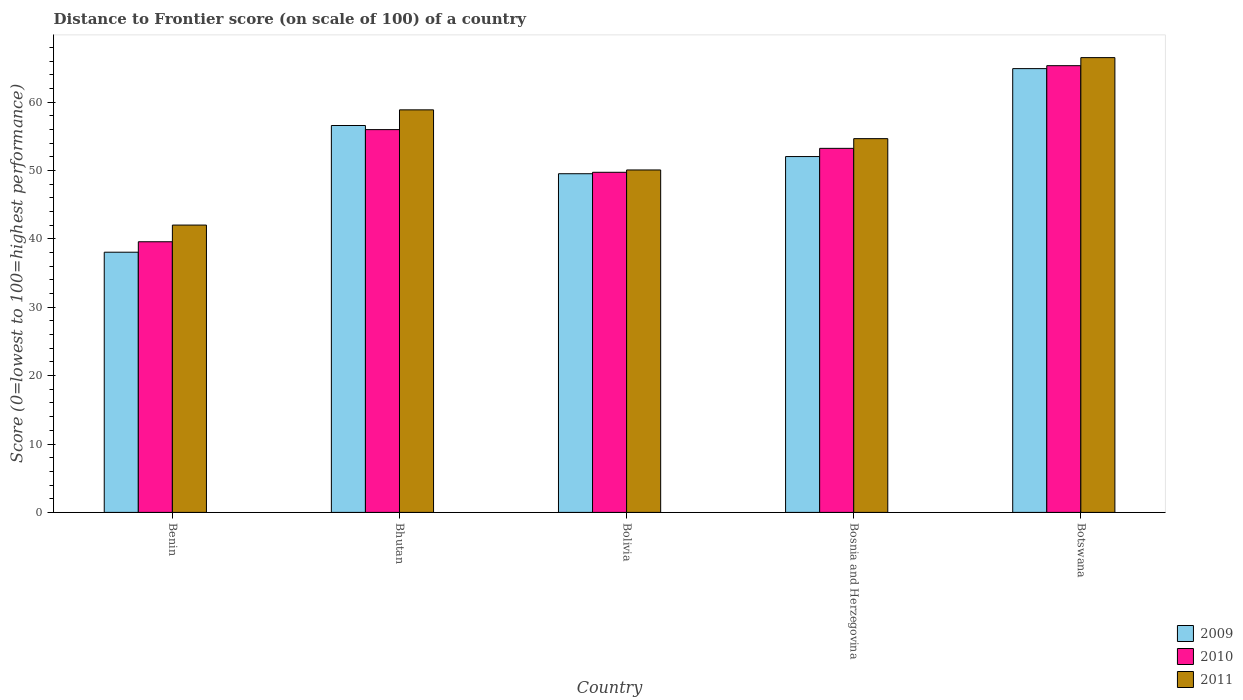How many different coloured bars are there?
Ensure brevity in your answer.  3. How many groups of bars are there?
Keep it short and to the point. 5. Are the number of bars per tick equal to the number of legend labels?
Your answer should be very brief. Yes. Are the number of bars on each tick of the X-axis equal?
Ensure brevity in your answer.  Yes. How many bars are there on the 5th tick from the left?
Your answer should be compact. 3. What is the label of the 1st group of bars from the left?
Provide a succinct answer. Benin. What is the distance to frontier score of in 2010 in Bosnia and Herzegovina?
Provide a short and direct response. 53.24. Across all countries, what is the maximum distance to frontier score of in 2010?
Ensure brevity in your answer.  65.33. Across all countries, what is the minimum distance to frontier score of in 2010?
Make the answer very short. 39.58. In which country was the distance to frontier score of in 2011 maximum?
Ensure brevity in your answer.  Botswana. In which country was the distance to frontier score of in 2010 minimum?
Ensure brevity in your answer.  Benin. What is the total distance to frontier score of in 2009 in the graph?
Offer a terse response. 261.1. What is the difference between the distance to frontier score of in 2011 in Benin and that in Bosnia and Herzegovina?
Provide a short and direct response. -12.64. What is the difference between the distance to frontier score of in 2009 in Bhutan and the distance to frontier score of in 2011 in Botswana?
Offer a very short reply. -9.93. What is the average distance to frontier score of in 2009 per country?
Provide a short and direct response. 52.22. What is the difference between the distance to frontier score of of/in 2009 and distance to frontier score of of/in 2011 in Bhutan?
Your answer should be compact. -2.29. In how many countries, is the distance to frontier score of in 2011 greater than 58?
Provide a succinct answer. 2. What is the ratio of the distance to frontier score of in 2009 in Bolivia to that in Bosnia and Herzegovina?
Keep it short and to the point. 0.95. Is the difference between the distance to frontier score of in 2009 in Benin and Botswana greater than the difference between the distance to frontier score of in 2011 in Benin and Botswana?
Offer a very short reply. No. What is the difference between the highest and the second highest distance to frontier score of in 2010?
Give a very brief answer. 12.09. What is the difference between the highest and the lowest distance to frontier score of in 2010?
Provide a succinct answer. 25.75. What does the 3rd bar from the left in Bolivia represents?
Your answer should be compact. 2011. How many bars are there?
Provide a succinct answer. 15. Are all the bars in the graph horizontal?
Provide a short and direct response. No. How many countries are there in the graph?
Give a very brief answer. 5. What is the title of the graph?
Provide a succinct answer. Distance to Frontier score (on scale of 100) of a country. Does "1990" appear as one of the legend labels in the graph?
Give a very brief answer. No. What is the label or title of the Y-axis?
Your answer should be very brief. Score (0=lowest to 100=highest performance). What is the Score (0=lowest to 100=highest performance) of 2009 in Benin?
Give a very brief answer. 38.05. What is the Score (0=lowest to 100=highest performance) of 2010 in Benin?
Keep it short and to the point. 39.58. What is the Score (0=lowest to 100=highest performance) in 2011 in Benin?
Make the answer very short. 42.02. What is the Score (0=lowest to 100=highest performance) of 2009 in Bhutan?
Keep it short and to the point. 56.58. What is the Score (0=lowest to 100=highest performance) in 2010 in Bhutan?
Ensure brevity in your answer.  55.98. What is the Score (0=lowest to 100=highest performance) in 2011 in Bhutan?
Offer a terse response. 58.87. What is the Score (0=lowest to 100=highest performance) in 2009 in Bolivia?
Ensure brevity in your answer.  49.53. What is the Score (0=lowest to 100=highest performance) in 2010 in Bolivia?
Ensure brevity in your answer.  49.74. What is the Score (0=lowest to 100=highest performance) of 2011 in Bolivia?
Keep it short and to the point. 50.08. What is the Score (0=lowest to 100=highest performance) in 2009 in Bosnia and Herzegovina?
Your response must be concise. 52.04. What is the Score (0=lowest to 100=highest performance) in 2010 in Bosnia and Herzegovina?
Offer a terse response. 53.24. What is the Score (0=lowest to 100=highest performance) of 2011 in Bosnia and Herzegovina?
Provide a succinct answer. 54.66. What is the Score (0=lowest to 100=highest performance) of 2009 in Botswana?
Ensure brevity in your answer.  64.9. What is the Score (0=lowest to 100=highest performance) in 2010 in Botswana?
Your answer should be very brief. 65.33. What is the Score (0=lowest to 100=highest performance) of 2011 in Botswana?
Provide a short and direct response. 66.51. Across all countries, what is the maximum Score (0=lowest to 100=highest performance) of 2009?
Provide a succinct answer. 64.9. Across all countries, what is the maximum Score (0=lowest to 100=highest performance) in 2010?
Make the answer very short. 65.33. Across all countries, what is the maximum Score (0=lowest to 100=highest performance) in 2011?
Your response must be concise. 66.51. Across all countries, what is the minimum Score (0=lowest to 100=highest performance) in 2009?
Your response must be concise. 38.05. Across all countries, what is the minimum Score (0=lowest to 100=highest performance) of 2010?
Offer a terse response. 39.58. Across all countries, what is the minimum Score (0=lowest to 100=highest performance) in 2011?
Ensure brevity in your answer.  42.02. What is the total Score (0=lowest to 100=highest performance) of 2009 in the graph?
Make the answer very short. 261.1. What is the total Score (0=lowest to 100=highest performance) of 2010 in the graph?
Your answer should be compact. 263.87. What is the total Score (0=lowest to 100=highest performance) in 2011 in the graph?
Your answer should be very brief. 272.14. What is the difference between the Score (0=lowest to 100=highest performance) of 2009 in Benin and that in Bhutan?
Provide a succinct answer. -18.53. What is the difference between the Score (0=lowest to 100=highest performance) of 2010 in Benin and that in Bhutan?
Make the answer very short. -16.4. What is the difference between the Score (0=lowest to 100=highest performance) in 2011 in Benin and that in Bhutan?
Your answer should be compact. -16.85. What is the difference between the Score (0=lowest to 100=highest performance) in 2009 in Benin and that in Bolivia?
Keep it short and to the point. -11.48. What is the difference between the Score (0=lowest to 100=highest performance) in 2010 in Benin and that in Bolivia?
Ensure brevity in your answer.  -10.16. What is the difference between the Score (0=lowest to 100=highest performance) of 2011 in Benin and that in Bolivia?
Offer a terse response. -8.06. What is the difference between the Score (0=lowest to 100=highest performance) in 2009 in Benin and that in Bosnia and Herzegovina?
Offer a very short reply. -13.99. What is the difference between the Score (0=lowest to 100=highest performance) of 2010 in Benin and that in Bosnia and Herzegovina?
Your answer should be compact. -13.66. What is the difference between the Score (0=lowest to 100=highest performance) of 2011 in Benin and that in Bosnia and Herzegovina?
Ensure brevity in your answer.  -12.64. What is the difference between the Score (0=lowest to 100=highest performance) in 2009 in Benin and that in Botswana?
Give a very brief answer. -26.85. What is the difference between the Score (0=lowest to 100=highest performance) in 2010 in Benin and that in Botswana?
Provide a succinct answer. -25.75. What is the difference between the Score (0=lowest to 100=highest performance) of 2011 in Benin and that in Botswana?
Give a very brief answer. -24.49. What is the difference between the Score (0=lowest to 100=highest performance) in 2009 in Bhutan and that in Bolivia?
Keep it short and to the point. 7.05. What is the difference between the Score (0=lowest to 100=highest performance) of 2010 in Bhutan and that in Bolivia?
Provide a short and direct response. 6.24. What is the difference between the Score (0=lowest to 100=highest performance) of 2011 in Bhutan and that in Bolivia?
Keep it short and to the point. 8.79. What is the difference between the Score (0=lowest to 100=highest performance) of 2009 in Bhutan and that in Bosnia and Herzegovina?
Your answer should be very brief. 4.54. What is the difference between the Score (0=lowest to 100=highest performance) of 2010 in Bhutan and that in Bosnia and Herzegovina?
Your answer should be compact. 2.74. What is the difference between the Score (0=lowest to 100=highest performance) of 2011 in Bhutan and that in Bosnia and Herzegovina?
Your answer should be compact. 4.21. What is the difference between the Score (0=lowest to 100=highest performance) of 2009 in Bhutan and that in Botswana?
Provide a succinct answer. -8.32. What is the difference between the Score (0=lowest to 100=highest performance) of 2010 in Bhutan and that in Botswana?
Give a very brief answer. -9.35. What is the difference between the Score (0=lowest to 100=highest performance) of 2011 in Bhutan and that in Botswana?
Offer a terse response. -7.64. What is the difference between the Score (0=lowest to 100=highest performance) of 2009 in Bolivia and that in Bosnia and Herzegovina?
Give a very brief answer. -2.51. What is the difference between the Score (0=lowest to 100=highest performance) in 2010 in Bolivia and that in Bosnia and Herzegovina?
Your response must be concise. -3.5. What is the difference between the Score (0=lowest to 100=highest performance) of 2011 in Bolivia and that in Bosnia and Herzegovina?
Offer a very short reply. -4.58. What is the difference between the Score (0=lowest to 100=highest performance) in 2009 in Bolivia and that in Botswana?
Ensure brevity in your answer.  -15.37. What is the difference between the Score (0=lowest to 100=highest performance) in 2010 in Bolivia and that in Botswana?
Your answer should be compact. -15.59. What is the difference between the Score (0=lowest to 100=highest performance) of 2011 in Bolivia and that in Botswana?
Provide a short and direct response. -16.43. What is the difference between the Score (0=lowest to 100=highest performance) of 2009 in Bosnia and Herzegovina and that in Botswana?
Provide a short and direct response. -12.86. What is the difference between the Score (0=lowest to 100=highest performance) in 2010 in Bosnia and Herzegovina and that in Botswana?
Offer a very short reply. -12.09. What is the difference between the Score (0=lowest to 100=highest performance) of 2011 in Bosnia and Herzegovina and that in Botswana?
Your answer should be compact. -11.85. What is the difference between the Score (0=lowest to 100=highest performance) in 2009 in Benin and the Score (0=lowest to 100=highest performance) in 2010 in Bhutan?
Offer a terse response. -17.93. What is the difference between the Score (0=lowest to 100=highest performance) in 2009 in Benin and the Score (0=lowest to 100=highest performance) in 2011 in Bhutan?
Offer a terse response. -20.82. What is the difference between the Score (0=lowest to 100=highest performance) in 2010 in Benin and the Score (0=lowest to 100=highest performance) in 2011 in Bhutan?
Keep it short and to the point. -19.29. What is the difference between the Score (0=lowest to 100=highest performance) in 2009 in Benin and the Score (0=lowest to 100=highest performance) in 2010 in Bolivia?
Give a very brief answer. -11.69. What is the difference between the Score (0=lowest to 100=highest performance) of 2009 in Benin and the Score (0=lowest to 100=highest performance) of 2011 in Bolivia?
Keep it short and to the point. -12.03. What is the difference between the Score (0=lowest to 100=highest performance) in 2010 in Benin and the Score (0=lowest to 100=highest performance) in 2011 in Bolivia?
Keep it short and to the point. -10.5. What is the difference between the Score (0=lowest to 100=highest performance) in 2009 in Benin and the Score (0=lowest to 100=highest performance) in 2010 in Bosnia and Herzegovina?
Keep it short and to the point. -15.19. What is the difference between the Score (0=lowest to 100=highest performance) in 2009 in Benin and the Score (0=lowest to 100=highest performance) in 2011 in Bosnia and Herzegovina?
Your answer should be compact. -16.61. What is the difference between the Score (0=lowest to 100=highest performance) of 2010 in Benin and the Score (0=lowest to 100=highest performance) of 2011 in Bosnia and Herzegovina?
Provide a short and direct response. -15.08. What is the difference between the Score (0=lowest to 100=highest performance) of 2009 in Benin and the Score (0=lowest to 100=highest performance) of 2010 in Botswana?
Give a very brief answer. -27.28. What is the difference between the Score (0=lowest to 100=highest performance) in 2009 in Benin and the Score (0=lowest to 100=highest performance) in 2011 in Botswana?
Keep it short and to the point. -28.46. What is the difference between the Score (0=lowest to 100=highest performance) in 2010 in Benin and the Score (0=lowest to 100=highest performance) in 2011 in Botswana?
Give a very brief answer. -26.93. What is the difference between the Score (0=lowest to 100=highest performance) of 2009 in Bhutan and the Score (0=lowest to 100=highest performance) of 2010 in Bolivia?
Your answer should be compact. 6.84. What is the difference between the Score (0=lowest to 100=highest performance) of 2009 in Bhutan and the Score (0=lowest to 100=highest performance) of 2011 in Bolivia?
Provide a short and direct response. 6.5. What is the difference between the Score (0=lowest to 100=highest performance) in 2009 in Bhutan and the Score (0=lowest to 100=highest performance) in 2010 in Bosnia and Herzegovina?
Give a very brief answer. 3.34. What is the difference between the Score (0=lowest to 100=highest performance) of 2009 in Bhutan and the Score (0=lowest to 100=highest performance) of 2011 in Bosnia and Herzegovina?
Provide a short and direct response. 1.92. What is the difference between the Score (0=lowest to 100=highest performance) of 2010 in Bhutan and the Score (0=lowest to 100=highest performance) of 2011 in Bosnia and Herzegovina?
Offer a very short reply. 1.32. What is the difference between the Score (0=lowest to 100=highest performance) in 2009 in Bhutan and the Score (0=lowest to 100=highest performance) in 2010 in Botswana?
Your answer should be compact. -8.75. What is the difference between the Score (0=lowest to 100=highest performance) of 2009 in Bhutan and the Score (0=lowest to 100=highest performance) of 2011 in Botswana?
Keep it short and to the point. -9.93. What is the difference between the Score (0=lowest to 100=highest performance) of 2010 in Bhutan and the Score (0=lowest to 100=highest performance) of 2011 in Botswana?
Offer a terse response. -10.53. What is the difference between the Score (0=lowest to 100=highest performance) in 2009 in Bolivia and the Score (0=lowest to 100=highest performance) in 2010 in Bosnia and Herzegovina?
Give a very brief answer. -3.71. What is the difference between the Score (0=lowest to 100=highest performance) of 2009 in Bolivia and the Score (0=lowest to 100=highest performance) of 2011 in Bosnia and Herzegovina?
Your response must be concise. -5.13. What is the difference between the Score (0=lowest to 100=highest performance) of 2010 in Bolivia and the Score (0=lowest to 100=highest performance) of 2011 in Bosnia and Herzegovina?
Keep it short and to the point. -4.92. What is the difference between the Score (0=lowest to 100=highest performance) of 2009 in Bolivia and the Score (0=lowest to 100=highest performance) of 2010 in Botswana?
Offer a very short reply. -15.8. What is the difference between the Score (0=lowest to 100=highest performance) of 2009 in Bolivia and the Score (0=lowest to 100=highest performance) of 2011 in Botswana?
Make the answer very short. -16.98. What is the difference between the Score (0=lowest to 100=highest performance) of 2010 in Bolivia and the Score (0=lowest to 100=highest performance) of 2011 in Botswana?
Make the answer very short. -16.77. What is the difference between the Score (0=lowest to 100=highest performance) of 2009 in Bosnia and Herzegovina and the Score (0=lowest to 100=highest performance) of 2010 in Botswana?
Provide a short and direct response. -13.29. What is the difference between the Score (0=lowest to 100=highest performance) of 2009 in Bosnia and Herzegovina and the Score (0=lowest to 100=highest performance) of 2011 in Botswana?
Your response must be concise. -14.47. What is the difference between the Score (0=lowest to 100=highest performance) of 2010 in Bosnia and Herzegovina and the Score (0=lowest to 100=highest performance) of 2011 in Botswana?
Ensure brevity in your answer.  -13.27. What is the average Score (0=lowest to 100=highest performance) of 2009 per country?
Your answer should be very brief. 52.22. What is the average Score (0=lowest to 100=highest performance) of 2010 per country?
Your answer should be very brief. 52.77. What is the average Score (0=lowest to 100=highest performance) of 2011 per country?
Provide a succinct answer. 54.43. What is the difference between the Score (0=lowest to 100=highest performance) in 2009 and Score (0=lowest to 100=highest performance) in 2010 in Benin?
Provide a short and direct response. -1.53. What is the difference between the Score (0=lowest to 100=highest performance) of 2009 and Score (0=lowest to 100=highest performance) of 2011 in Benin?
Provide a succinct answer. -3.97. What is the difference between the Score (0=lowest to 100=highest performance) in 2010 and Score (0=lowest to 100=highest performance) in 2011 in Benin?
Your response must be concise. -2.44. What is the difference between the Score (0=lowest to 100=highest performance) of 2009 and Score (0=lowest to 100=highest performance) of 2011 in Bhutan?
Provide a short and direct response. -2.29. What is the difference between the Score (0=lowest to 100=highest performance) of 2010 and Score (0=lowest to 100=highest performance) of 2011 in Bhutan?
Your response must be concise. -2.89. What is the difference between the Score (0=lowest to 100=highest performance) in 2009 and Score (0=lowest to 100=highest performance) in 2010 in Bolivia?
Offer a terse response. -0.21. What is the difference between the Score (0=lowest to 100=highest performance) of 2009 and Score (0=lowest to 100=highest performance) of 2011 in Bolivia?
Your answer should be compact. -0.55. What is the difference between the Score (0=lowest to 100=highest performance) in 2010 and Score (0=lowest to 100=highest performance) in 2011 in Bolivia?
Your answer should be compact. -0.34. What is the difference between the Score (0=lowest to 100=highest performance) of 2009 and Score (0=lowest to 100=highest performance) of 2010 in Bosnia and Herzegovina?
Provide a succinct answer. -1.2. What is the difference between the Score (0=lowest to 100=highest performance) in 2009 and Score (0=lowest to 100=highest performance) in 2011 in Bosnia and Herzegovina?
Provide a succinct answer. -2.62. What is the difference between the Score (0=lowest to 100=highest performance) in 2010 and Score (0=lowest to 100=highest performance) in 2011 in Bosnia and Herzegovina?
Keep it short and to the point. -1.42. What is the difference between the Score (0=lowest to 100=highest performance) in 2009 and Score (0=lowest to 100=highest performance) in 2010 in Botswana?
Your answer should be very brief. -0.43. What is the difference between the Score (0=lowest to 100=highest performance) in 2009 and Score (0=lowest to 100=highest performance) in 2011 in Botswana?
Ensure brevity in your answer.  -1.61. What is the difference between the Score (0=lowest to 100=highest performance) of 2010 and Score (0=lowest to 100=highest performance) of 2011 in Botswana?
Provide a short and direct response. -1.18. What is the ratio of the Score (0=lowest to 100=highest performance) in 2009 in Benin to that in Bhutan?
Offer a terse response. 0.67. What is the ratio of the Score (0=lowest to 100=highest performance) of 2010 in Benin to that in Bhutan?
Give a very brief answer. 0.71. What is the ratio of the Score (0=lowest to 100=highest performance) of 2011 in Benin to that in Bhutan?
Make the answer very short. 0.71. What is the ratio of the Score (0=lowest to 100=highest performance) of 2009 in Benin to that in Bolivia?
Your answer should be compact. 0.77. What is the ratio of the Score (0=lowest to 100=highest performance) of 2010 in Benin to that in Bolivia?
Ensure brevity in your answer.  0.8. What is the ratio of the Score (0=lowest to 100=highest performance) of 2011 in Benin to that in Bolivia?
Provide a short and direct response. 0.84. What is the ratio of the Score (0=lowest to 100=highest performance) of 2009 in Benin to that in Bosnia and Herzegovina?
Your answer should be very brief. 0.73. What is the ratio of the Score (0=lowest to 100=highest performance) of 2010 in Benin to that in Bosnia and Herzegovina?
Your answer should be compact. 0.74. What is the ratio of the Score (0=lowest to 100=highest performance) of 2011 in Benin to that in Bosnia and Herzegovina?
Provide a short and direct response. 0.77. What is the ratio of the Score (0=lowest to 100=highest performance) of 2009 in Benin to that in Botswana?
Provide a short and direct response. 0.59. What is the ratio of the Score (0=lowest to 100=highest performance) of 2010 in Benin to that in Botswana?
Make the answer very short. 0.61. What is the ratio of the Score (0=lowest to 100=highest performance) in 2011 in Benin to that in Botswana?
Provide a succinct answer. 0.63. What is the ratio of the Score (0=lowest to 100=highest performance) of 2009 in Bhutan to that in Bolivia?
Provide a short and direct response. 1.14. What is the ratio of the Score (0=lowest to 100=highest performance) of 2010 in Bhutan to that in Bolivia?
Offer a terse response. 1.13. What is the ratio of the Score (0=lowest to 100=highest performance) in 2011 in Bhutan to that in Bolivia?
Offer a terse response. 1.18. What is the ratio of the Score (0=lowest to 100=highest performance) of 2009 in Bhutan to that in Bosnia and Herzegovina?
Provide a short and direct response. 1.09. What is the ratio of the Score (0=lowest to 100=highest performance) in 2010 in Bhutan to that in Bosnia and Herzegovina?
Make the answer very short. 1.05. What is the ratio of the Score (0=lowest to 100=highest performance) of 2011 in Bhutan to that in Bosnia and Herzegovina?
Make the answer very short. 1.08. What is the ratio of the Score (0=lowest to 100=highest performance) in 2009 in Bhutan to that in Botswana?
Your response must be concise. 0.87. What is the ratio of the Score (0=lowest to 100=highest performance) of 2010 in Bhutan to that in Botswana?
Keep it short and to the point. 0.86. What is the ratio of the Score (0=lowest to 100=highest performance) of 2011 in Bhutan to that in Botswana?
Offer a very short reply. 0.89. What is the ratio of the Score (0=lowest to 100=highest performance) in 2009 in Bolivia to that in Bosnia and Herzegovina?
Your answer should be compact. 0.95. What is the ratio of the Score (0=lowest to 100=highest performance) in 2010 in Bolivia to that in Bosnia and Herzegovina?
Provide a succinct answer. 0.93. What is the ratio of the Score (0=lowest to 100=highest performance) in 2011 in Bolivia to that in Bosnia and Herzegovina?
Keep it short and to the point. 0.92. What is the ratio of the Score (0=lowest to 100=highest performance) of 2009 in Bolivia to that in Botswana?
Make the answer very short. 0.76. What is the ratio of the Score (0=lowest to 100=highest performance) in 2010 in Bolivia to that in Botswana?
Your response must be concise. 0.76. What is the ratio of the Score (0=lowest to 100=highest performance) in 2011 in Bolivia to that in Botswana?
Offer a terse response. 0.75. What is the ratio of the Score (0=lowest to 100=highest performance) of 2009 in Bosnia and Herzegovina to that in Botswana?
Your answer should be very brief. 0.8. What is the ratio of the Score (0=lowest to 100=highest performance) of 2010 in Bosnia and Herzegovina to that in Botswana?
Your answer should be compact. 0.81. What is the ratio of the Score (0=lowest to 100=highest performance) in 2011 in Bosnia and Herzegovina to that in Botswana?
Make the answer very short. 0.82. What is the difference between the highest and the second highest Score (0=lowest to 100=highest performance) of 2009?
Provide a short and direct response. 8.32. What is the difference between the highest and the second highest Score (0=lowest to 100=highest performance) in 2010?
Give a very brief answer. 9.35. What is the difference between the highest and the second highest Score (0=lowest to 100=highest performance) of 2011?
Offer a terse response. 7.64. What is the difference between the highest and the lowest Score (0=lowest to 100=highest performance) in 2009?
Ensure brevity in your answer.  26.85. What is the difference between the highest and the lowest Score (0=lowest to 100=highest performance) of 2010?
Give a very brief answer. 25.75. What is the difference between the highest and the lowest Score (0=lowest to 100=highest performance) in 2011?
Give a very brief answer. 24.49. 